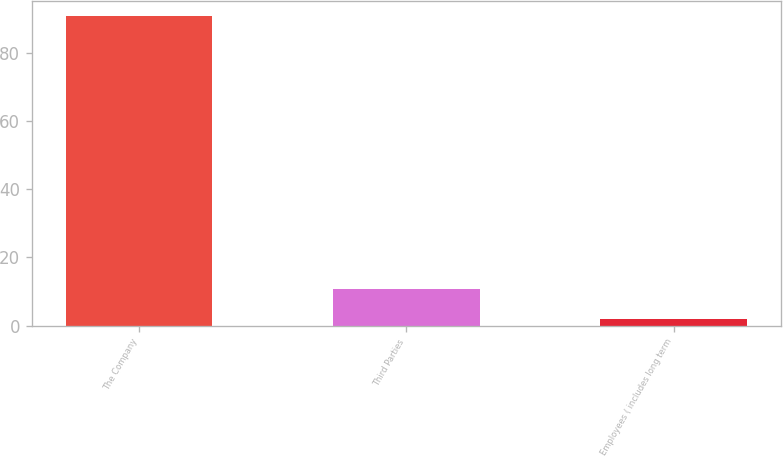Convert chart. <chart><loc_0><loc_0><loc_500><loc_500><bar_chart><fcel>The Company<fcel>Third Parties<fcel>Employees ( includes long term<nl><fcel>90.7<fcel>10.78<fcel>1.9<nl></chart> 